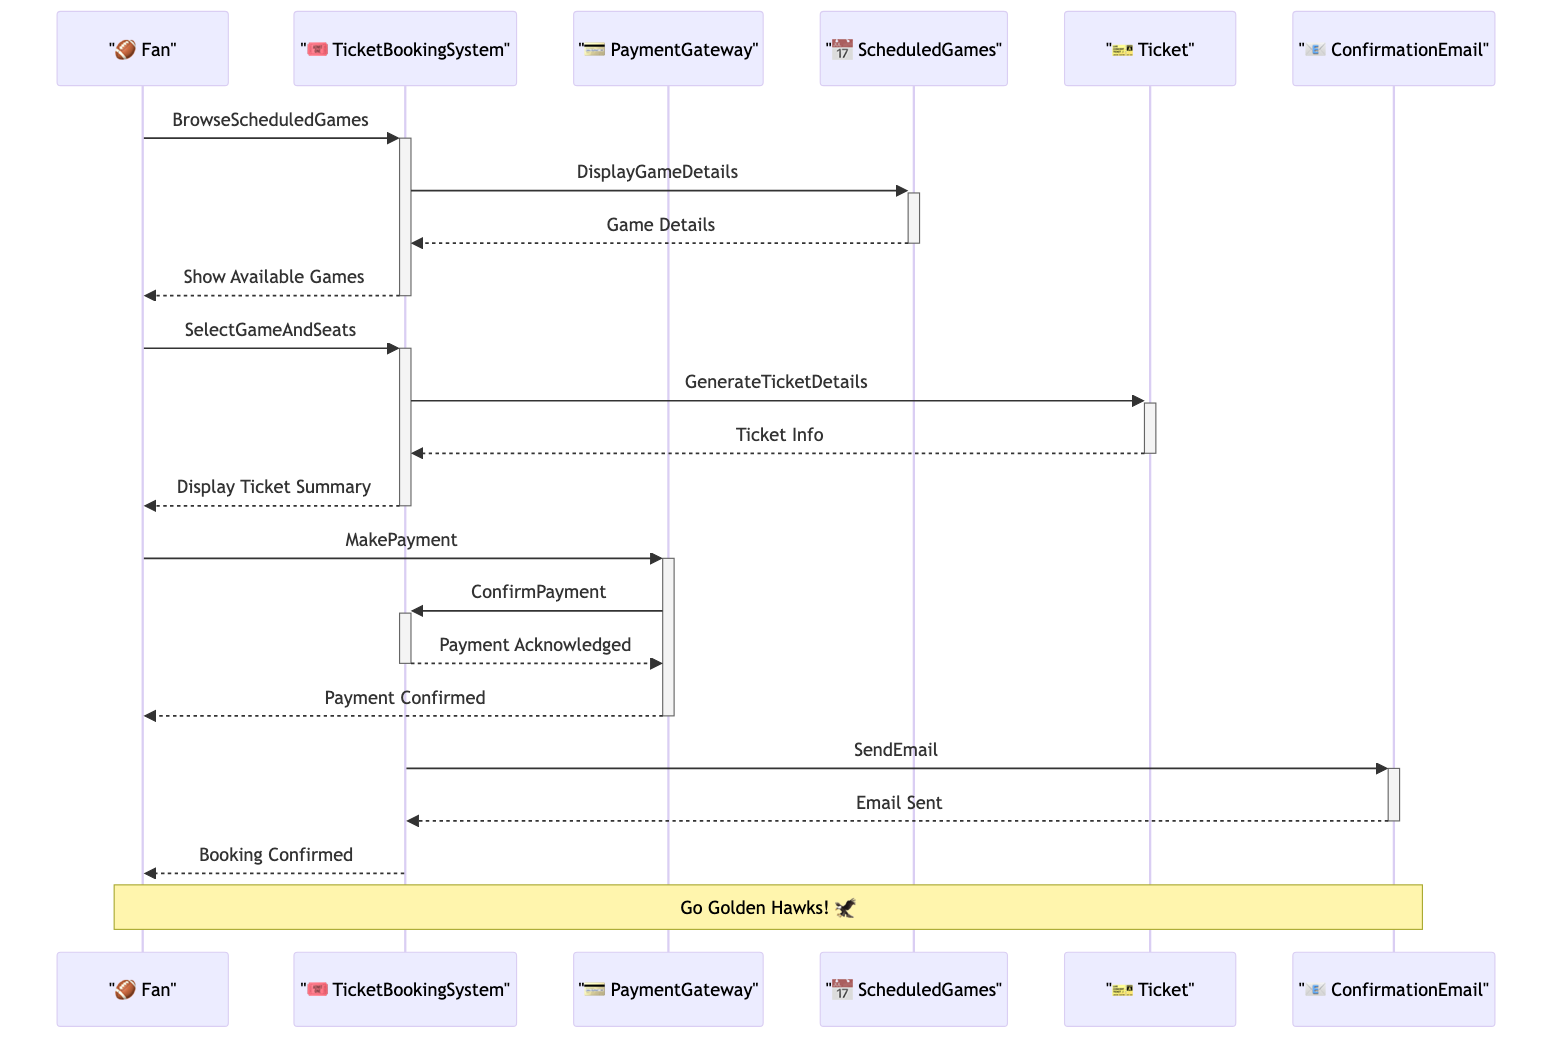What's the first action performed by the Fan? The first action performed by the Fan is "BrowseScheduledGames," where the Fan interacts with the TicketBookingSystem to look for available games.
Answer: BrowseScheduledGames What does the TicketBookingSystem display after receiving the browsing request? After the Fan requests to browse scheduled games, the TicketBookingSystem sends an action to ScheduledGames, which triggers the display of game details.
Answer: Game Details How many main participants are involved in the sequence diagram? There are four main participants: Fan, TicketBookingSystem, PaymentGateway, and ScheduledGames.
Answer: Four What is sent to the Fan after the payment confirmation? After the payment is confirmed, the TicketBookingSystem sends a "ConfirmationEmail" to the Fan, indicating that their booking has been finalized.
Answer: ConfirmationEmail What signifies the end of the ticket purchasing process in this diagram? The end of the ticket purchasing process is indicated by the final message from TicketBookingSystem to the Fan that the "Booking Confirmed," which shows that the entire transaction has been completed successfully.
Answer: Booking Confirmed Which entity generates the ticket details during the process? The entity that generates the ticket details is the "Ticket," which is created by the TicketBookingSystem after the Fan selects a game and preferred seats.
Answer: Ticket What is the action that the PaymentGateway performs to inform the TicketBookingSystem? The action performed by the PaymentGateway to inform the TicketBookingSystem is "ConfirmPayment," indicating that the payment has been successfully processed.
Answer: ConfirmPayment What is included in the final note of the diagram? The final note above the Fan and ConfirmationEmail indicates a cheering statement, "Go Golden Hawks!" which reflects the enthusiasm of the Fan for the Wilfrid Laurier University sports teams.
Answer: Go Golden Hawks! 